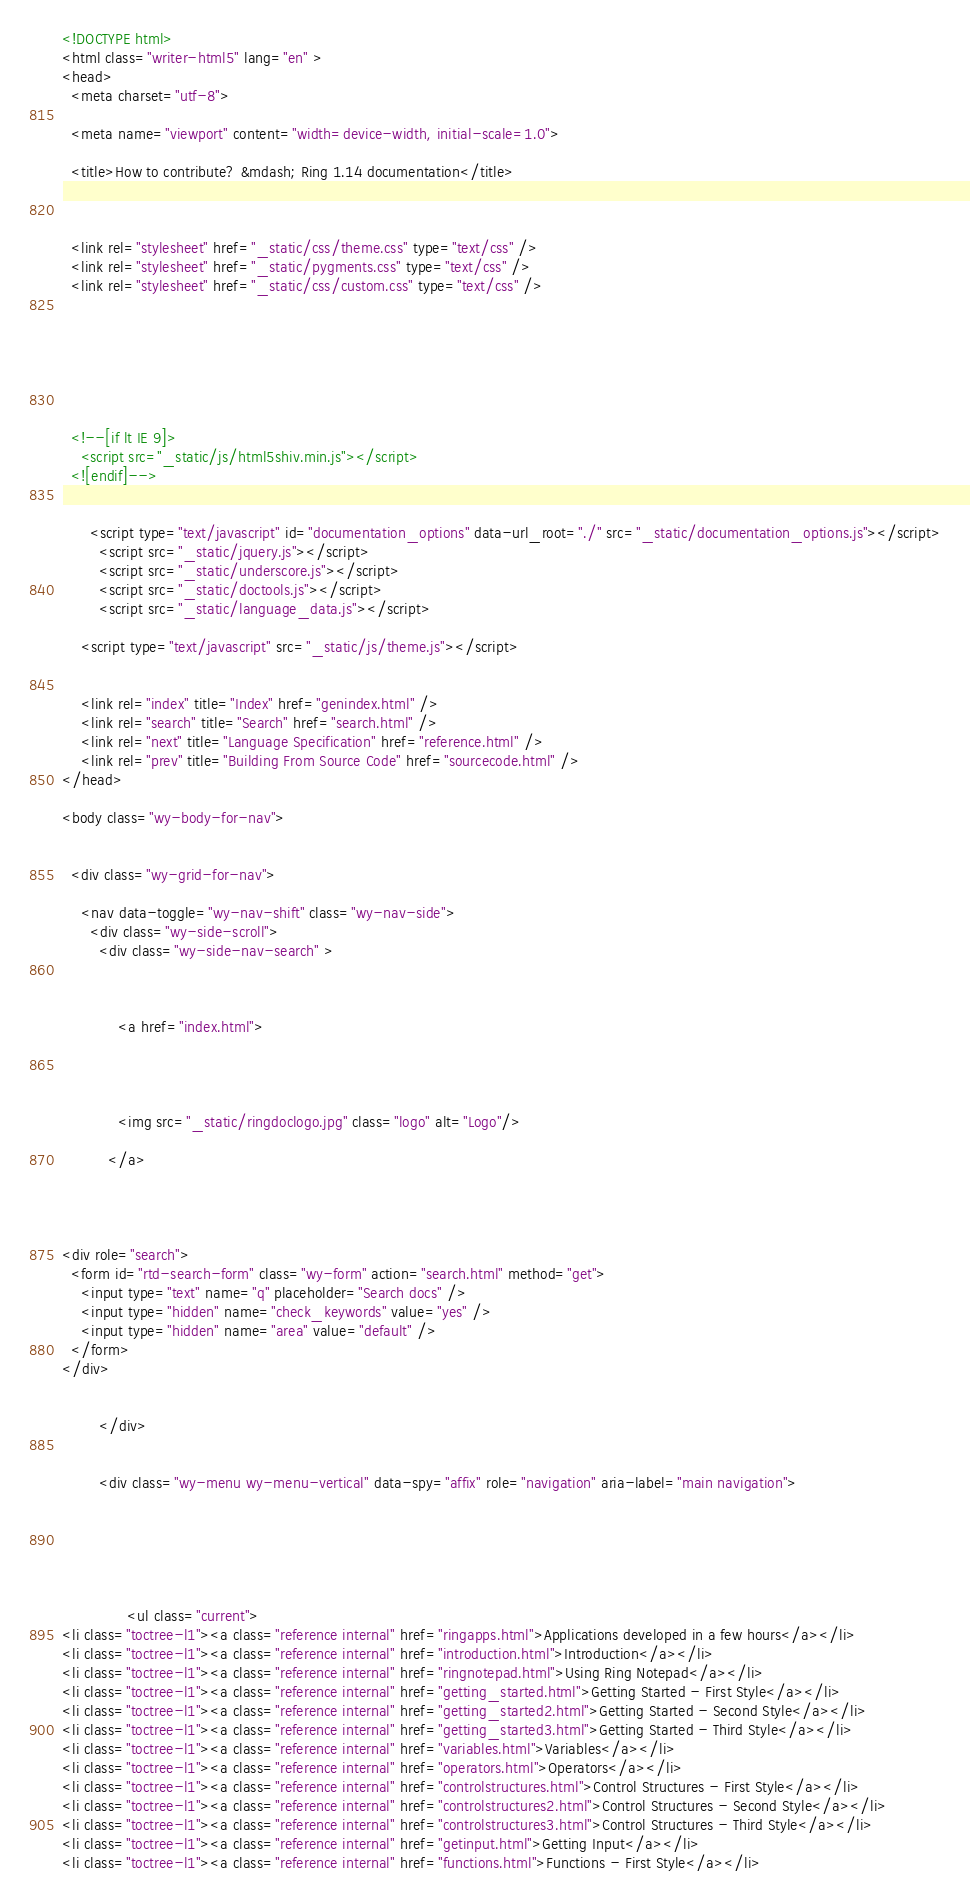<code> <loc_0><loc_0><loc_500><loc_500><_HTML_>

<!DOCTYPE html>
<html class="writer-html5" lang="en" >
<head>
  <meta charset="utf-8">
  
  <meta name="viewport" content="width=device-width, initial-scale=1.0">
  
  <title>How to contribute? &mdash; Ring 1.14 documentation</title>
  

  
  <link rel="stylesheet" href="_static/css/theme.css" type="text/css" />
  <link rel="stylesheet" href="_static/pygments.css" type="text/css" />
  <link rel="stylesheet" href="_static/css/custom.css" type="text/css" />

  
  
  
  

  
  <!--[if lt IE 9]>
    <script src="_static/js/html5shiv.min.js"></script>
  <![endif]-->
  
    
      <script type="text/javascript" id="documentation_options" data-url_root="./" src="_static/documentation_options.js"></script>
        <script src="_static/jquery.js"></script>
        <script src="_static/underscore.js"></script>
        <script src="_static/doctools.js"></script>
        <script src="_static/language_data.js"></script>
    
    <script type="text/javascript" src="_static/js/theme.js"></script>

    
    <link rel="index" title="Index" href="genindex.html" />
    <link rel="search" title="Search" href="search.html" />
    <link rel="next" title="Language Specification" href="reference.html" />
    <link rel="prev" title="Building From Source Code" href="sourcecode.html" /> 
</head>

<body class="wy-body-for-nav">

   
  <div class="wy-grid-for-nav">
    
    <nav data-toggle="wy-nav-shift" class="wy-nav-side">
      <div class="wy-side-scroll">
        <div class="wy-side-nav-search" >
          

          
            <a href="index.html">
          

          
            
            <img src="_static/ringdoclogo.jpg" class="logo" alt="Logo"/>
          
          </a>

          

          
<div role="search">
  <form id="rtd-search-form" class="wy-form" action="search.html" method="get">
    <input type="text" name="q" placeholder="Search docs" />
    <input type="hidden" name="check_keywords" value="yes" />
    <input type="hidden" name="area" value="default" />
  </form>
</div>

          
        </div>

        
        <div class="wy-menu wy-menu-vertical" data-spy="affix" role="navigation" aria-label="main navigation">
          
            
            
              
            
            
              <ul class="current">
<li class="toctree-l1"><a class="reference internal" href="ringapps.html">Applications developed in a few hours</a></li>
<li class="toctree-l1"><a class="reference internal" href="introduction.html">Introduction</a></li>
<li class="toctree-l1"><a class="reference internal" href="ringnotepad.html">Using Ring Notepad</a></li>
<li class="toctree-l1"><a class="reference internal" href="getting_started.html">Getting Started - First Style</a></li>
<li class="toctree-l1"><a class="reference internal" href="getting_started2.html">Getting Started - Second Style</a></li>
<li class="toctree-l1"><a class="reference internal" href="getting_started3.html">Getting Started - Third Style</a></li>
<li class="toctree-l1"><a class="reference internal" href="variables.html">Variables</a></li>
<li class="toctree-l1"><a class="reference internal" href="operators.html">Operators</a></li>
<li class="toctree-l1"><a class="reference internal" href="controlstructures.html">Control Structures - First Style</a></li>
<li class="toctree-l1"><a class="reference internal" href="controlstructures2.html">Control Structures - Second Style</a></li>
<li class="toctree-l1"><a class="reference internal" href="controlstructures3.html">Control Structures - Third Style</a></li>
<li class="toctree-l1"><a class="reference internal" href="getinput.html">Getting Input</a></li>
<li class="toctree-l1"><a class="reference internal" href="functions.html">Functions - First Style</a></li></code> 